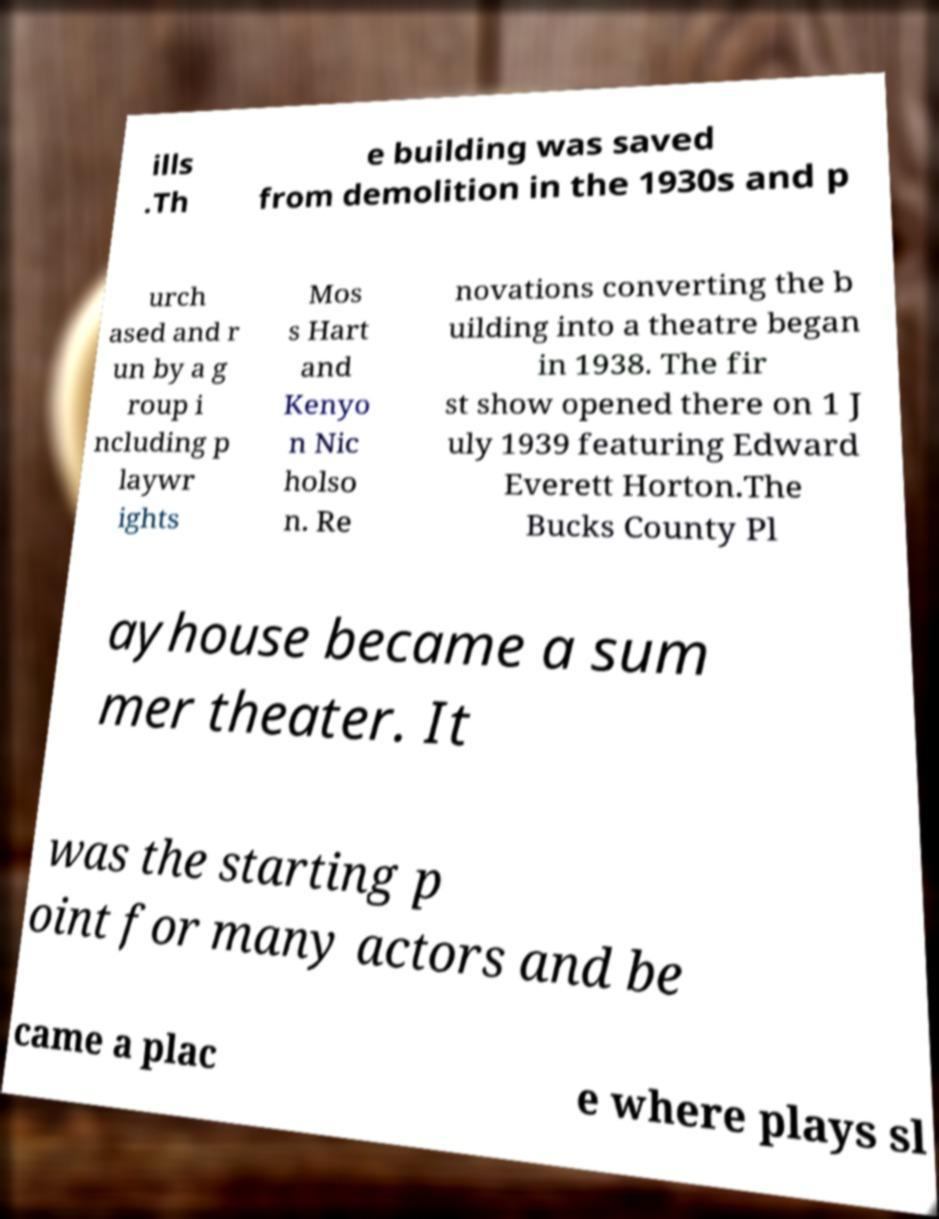Can you read and provide the text displayed in the image?This photo seems to have some interesting text. Can you extract and type it out for me? ills .Th e building was saved from demolition in the 1930s and p urch ased and r un by a g roup i ncluding p laywr ights Mos s Hart and Kenyo n Nic holso n. Re novations converting the b uilding into a theatre began in 1938. The fir st show opened there on 1 J uly 1939 featuring Edward Everett Horton.The Bucks County Pl ayhouse became a sum mer theater. It was the starting p oint for many actors and be came a plac e where plays sl 